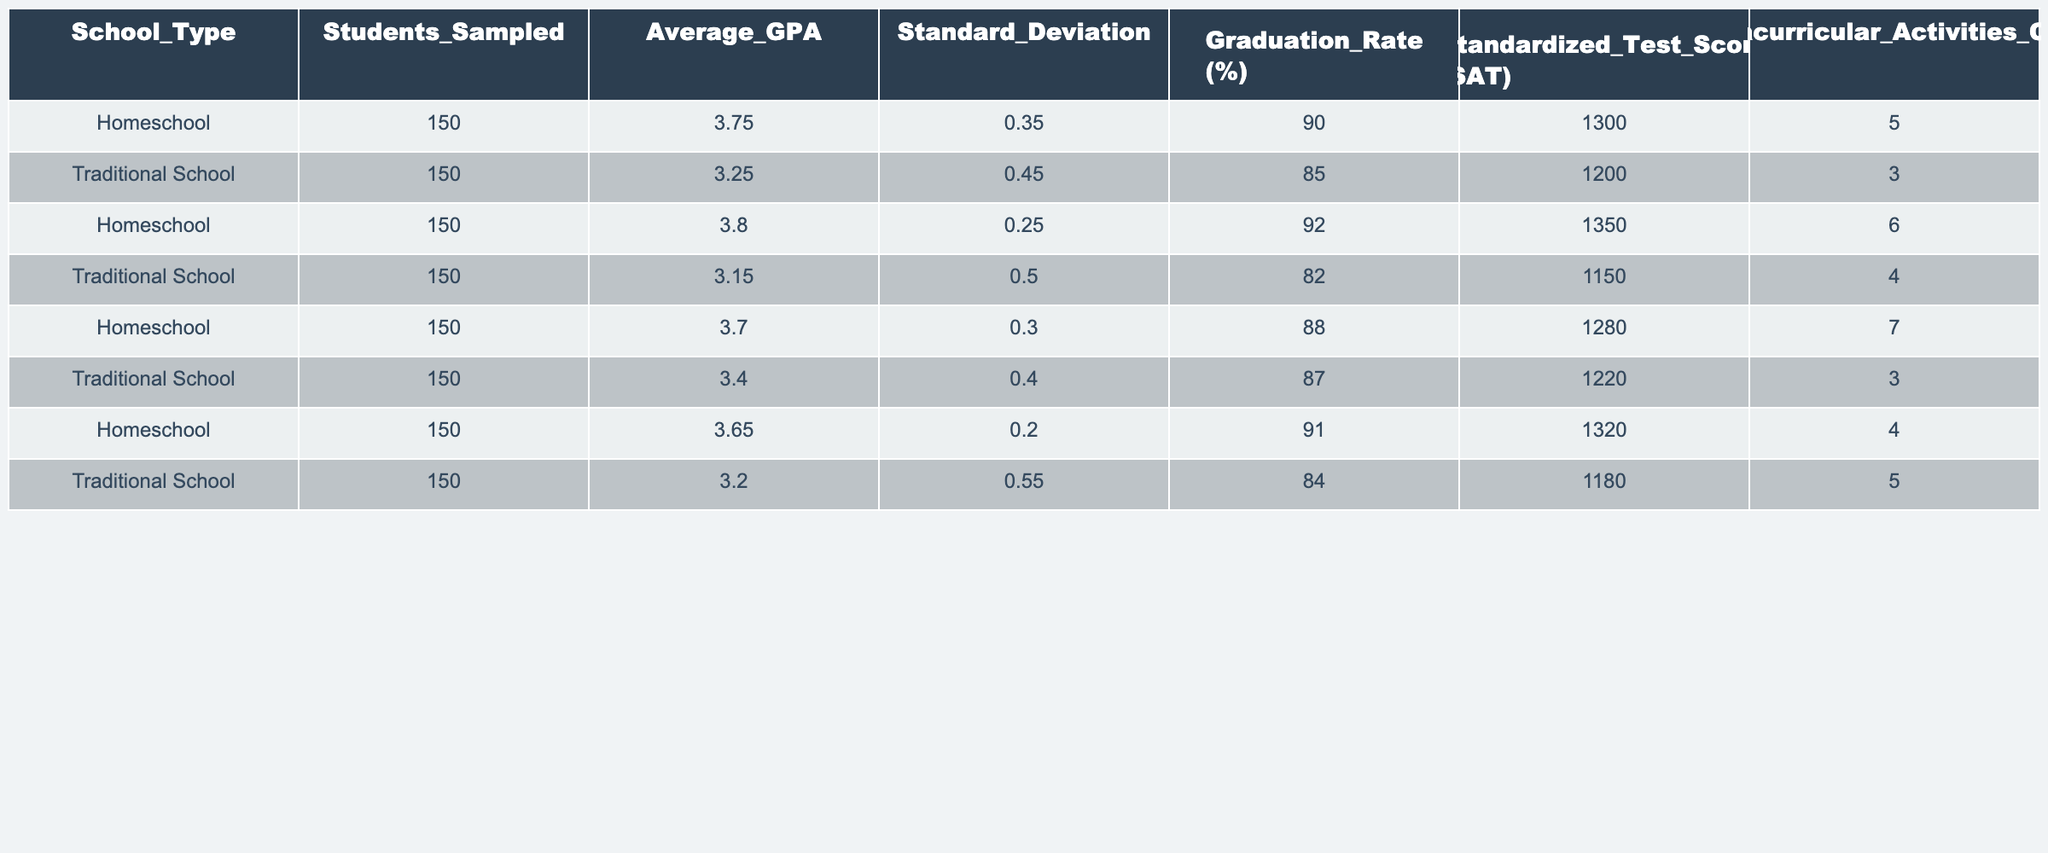What is the average GPA of homeschooled children? To find the average GPA for homeschooled children, sum the average GPAs of the four rows labeled "Homeschool": (3.75 + 3.80 + 3.70 + 3.65) = 15.90. Then, divide this sum by the number of data points (4): 15.90 / 4 = 3.975.
Answer: 3.975 What is the average standardized test score (SAT) for traditionally schooled children? The average SAT score for traditionally schooled children is found by summing the SAT scores of the four rows labeled "Traditional School": (1200 + 1150 + 1220 + 1180) = 4750. Dividing this sum by 4 gives the average: 4750 / 4 = 1187.5.
Answer: 1187.5 Which group has a higher average graduation rate? Compare the average graduation rates: Homeschooled average is (90 + 92 + 88 + 91) / 4 = 90.25% and Traditional School average is (85 + 82 + 87 + 84) / 4 = 84.5%. Since 90.25% > 84.5%, homeschooled children have a higher average graduation rate.
Answer: Homeschool What is the difference in average GPA between homeschooled and traditionally schooled children? Calculate the average GPA for both groups: Homeschooled average is 3.975, and traditionally schooled average is (3.25 + 3.15 + 3.40 + 3.20) / 4 = 3.225. The difference is 3.975 - 3.225 = 0.75.
Answer: 0.75 Is it true that the average number of extracurricular activities for homeschooled children is greater than that for traditionally schooled children? The average number of extracurricular activities for homeschool is (5 + 6 + 7 + 4) / 4 = 5.5 and for traditional school is (3 + 4 + 3 + 5) / 4 = 3.75. Since 5.5 > 3.75, it is true.
Answer: Yes What is the average of the standardized test scores of all students (both homeschooled and traditionally schooled)? Sum the SAT scores: (1300 + 1350 + 1280 + 1320 + 1200 + 1150 + 1220 + 1180) = 10800. With 8 data points, the average is 10800 / 8 = 1350.
Answer: 1350 Which school type has a greater standard deviation in GPA? Compare the standard deviations: Homeschooled is 0.35, 0.25, 0.30, 0.20 which averages to 0.2625; Traditional School is 0.45, 0.50, 0.40, 0.55 which averages to 0.4875. Since 0.4875 > 0.2625, Traditional School has a greater standard deviation in GPA.
Answer: Traditional School What is the total count of extracurricular activities for all homeschooled children? Sum the extracurricular activity counts: 5 + 6 + 7 + 4 = 22.
Answer: 22 